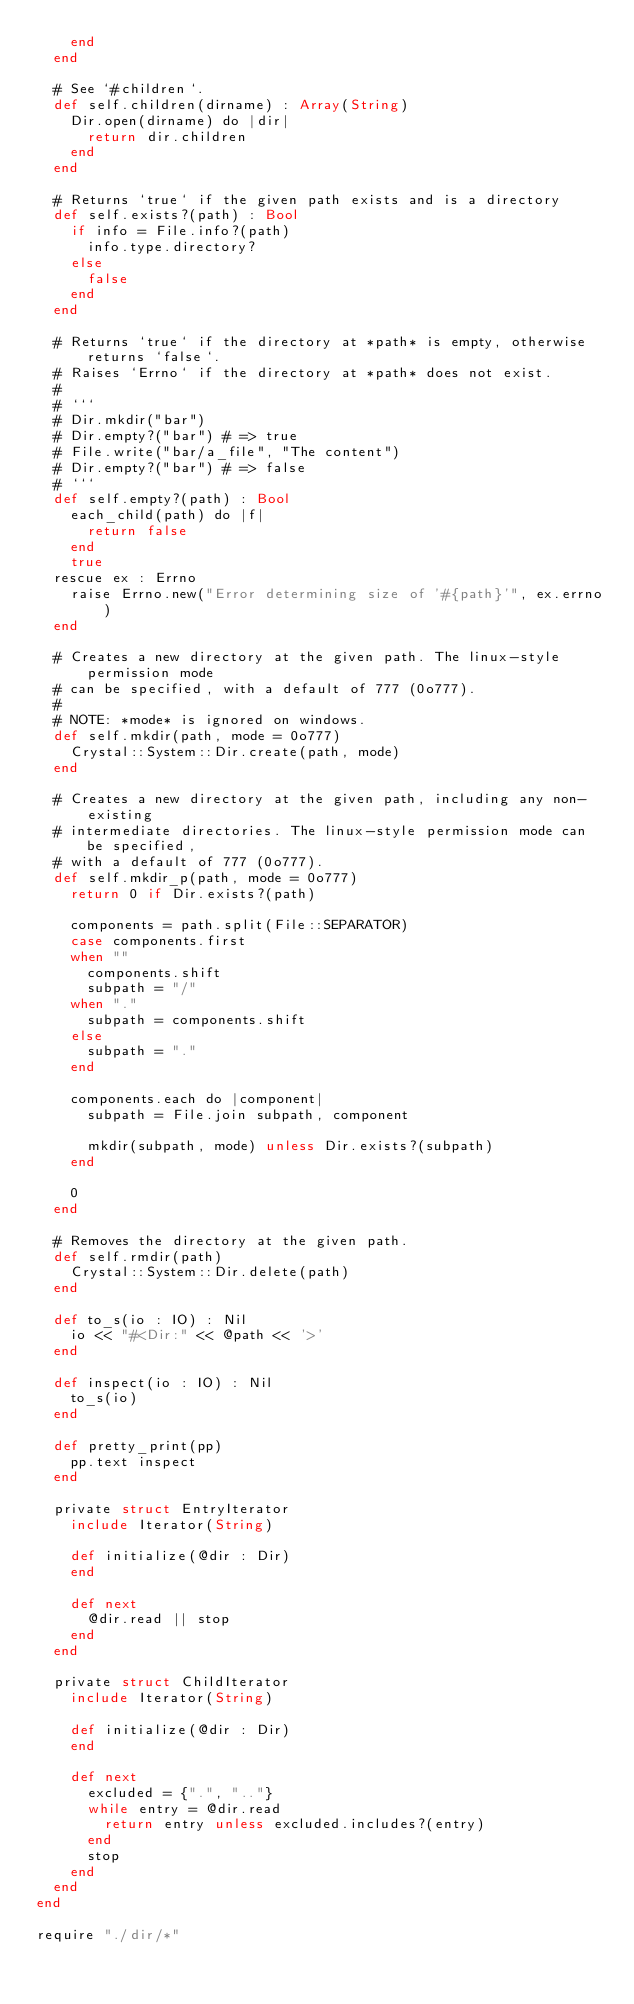<code> <loc_0><loc_0><loc_500><loc_500><_Crystal_>    end
  end

  # See `#children`.
  def self.children(dirname) : Array(String)
    Dir.open(dirname) do |dir|
      return dir.children
    end
  end

  # Returns `true` if the given path exists and is a directory
  def self.exists?(path) : Bool
    if info = File.info?(path)
      info.type.directory?
    else
      false
    end
  end

  # Returns `true` if the directory at *path* is empty, otherwise returns `false`.
  # Raises `Errno` if the directory at *path* does not exist.
  #
  # ```
  # Dir.mkdir("bar")
  # Dir.empty?("bar") # => true
  # File.write("bar/a_file", "The content")
  # Dir.empty?("bar") # => false
  # ```
  def self.empty?(path) : Bool
    each_child(path) do |f|
      return false
    end
    true
  rescue ex : Errno
    raise Errno.new("Error determining size of '#{path}'", ex.errno)
  end

  # Creates a new directory at the given path. The linux-style permission mode
  # can be specified, with a default of 777 (0o777).
  #
  # NOTE: *mode* is ignored on windows.
  def self.mkdir(path, mode = 0o777)
    Crystal::System::Dir.create(path, mode)
  end

  # Creates a new directory at the given path, including any non-existing
  # intermediate directories. The linux-style permission mode can be specified,
  # with a default of 777 (0o777).
  def self.mkdir_p(path, mode = 0o777)
    return 0 if Dir.exists?(path)

    components = path.split(File::SEPARATOR)
    case components.first
    when ""
      components.shift
      subpath = "/"
    when "."
      subpath = components.shift
    else
      subpath = "."
    end

    components.each do |component|
      subpath = File.join subpath, component

      mkdir(subpath, mode) unless Dir.exists?(subpath)
    end

    0
  end

  # Removes the directory at the given path.
  def self.rmdir(path)
    Crystal::System::Dir.delete(path)
  end

  def to_s(io : IO) : Nil
    io << "#<Dir:" << @path << '>'
  end

  def inspect(io : IO) : Nil
    to_s(io)
  end

  def pretty_print(pp)
    pp.text inspect
  end

  private struct EntryIterator
    include Iterator(String)

    def initialize(@dir : Dir)
    end

    def next
      @dir.read || stop
    end
  end

  private struct ChildIterator
    include Iterator(String)

    def initialize(@dir : Dir)
    end

    def next
      excluded = {".", ".."}
      while entry = @dir.read
        return entry unless excluded.includes?(entry)
      end
      stop
    end
  end
end

require "./dir/*"
</code> 